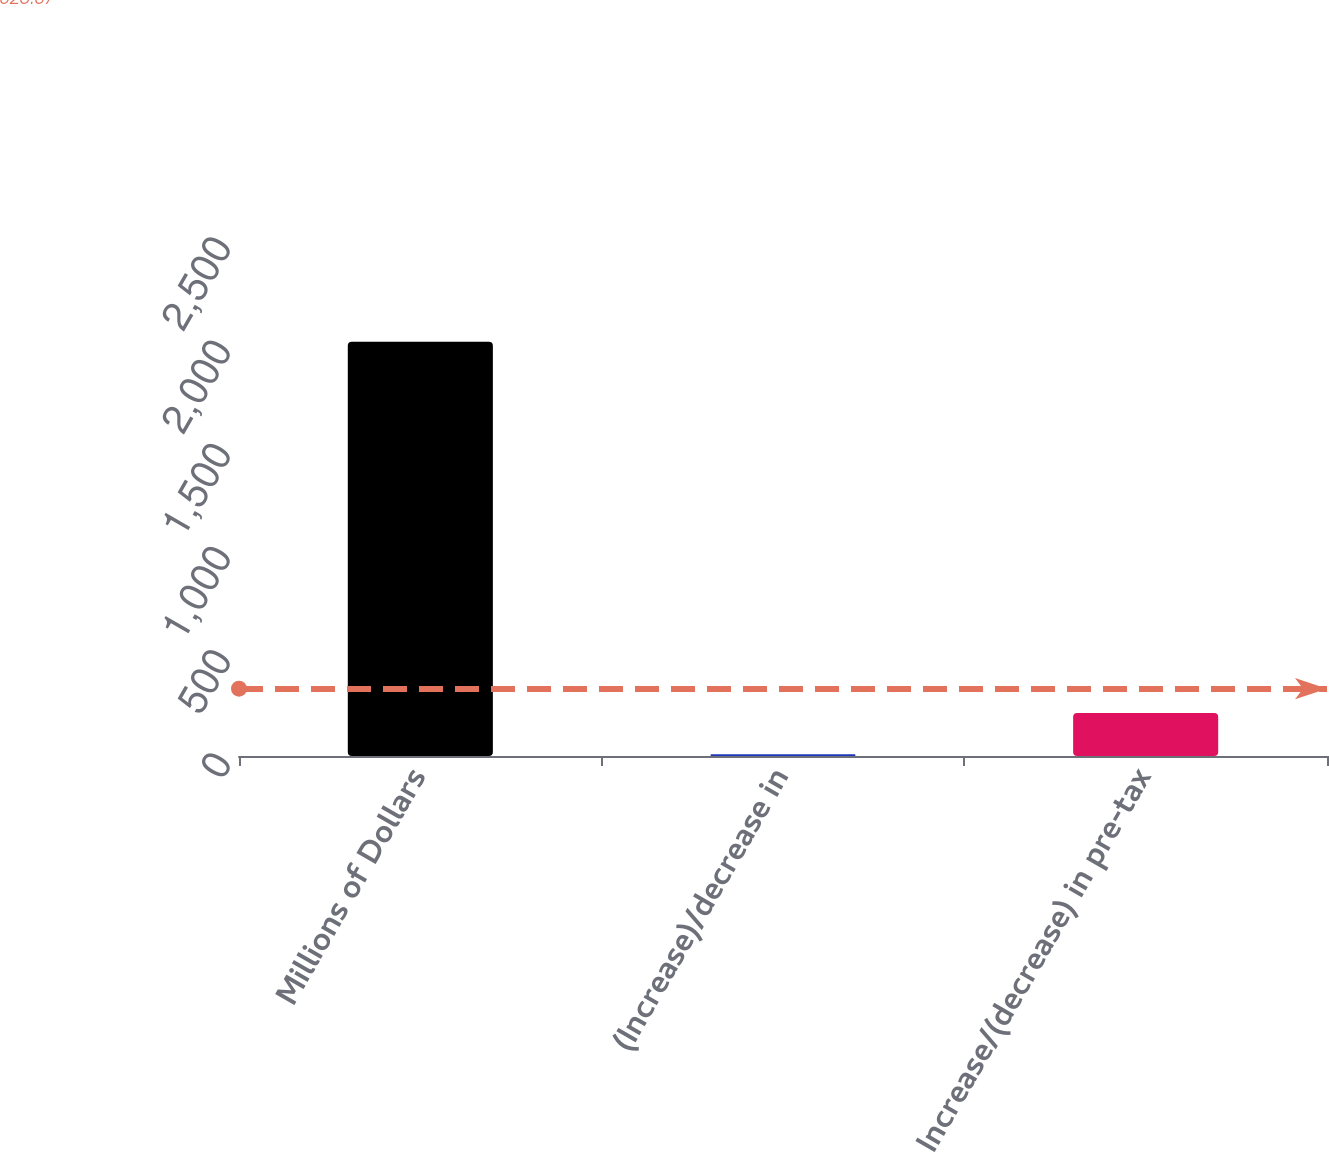Convert chart to OTSL. <chart><loc_0><loc_0><loc_500><loc_500><bar_chart><fcel>Millions of Dollars<fcel>(Increase)/decrease in<fcel>Increase/(decrease) in pre-tax<nl><fcel>2007<fcel>8<fcel>207.9<nl></chart> 